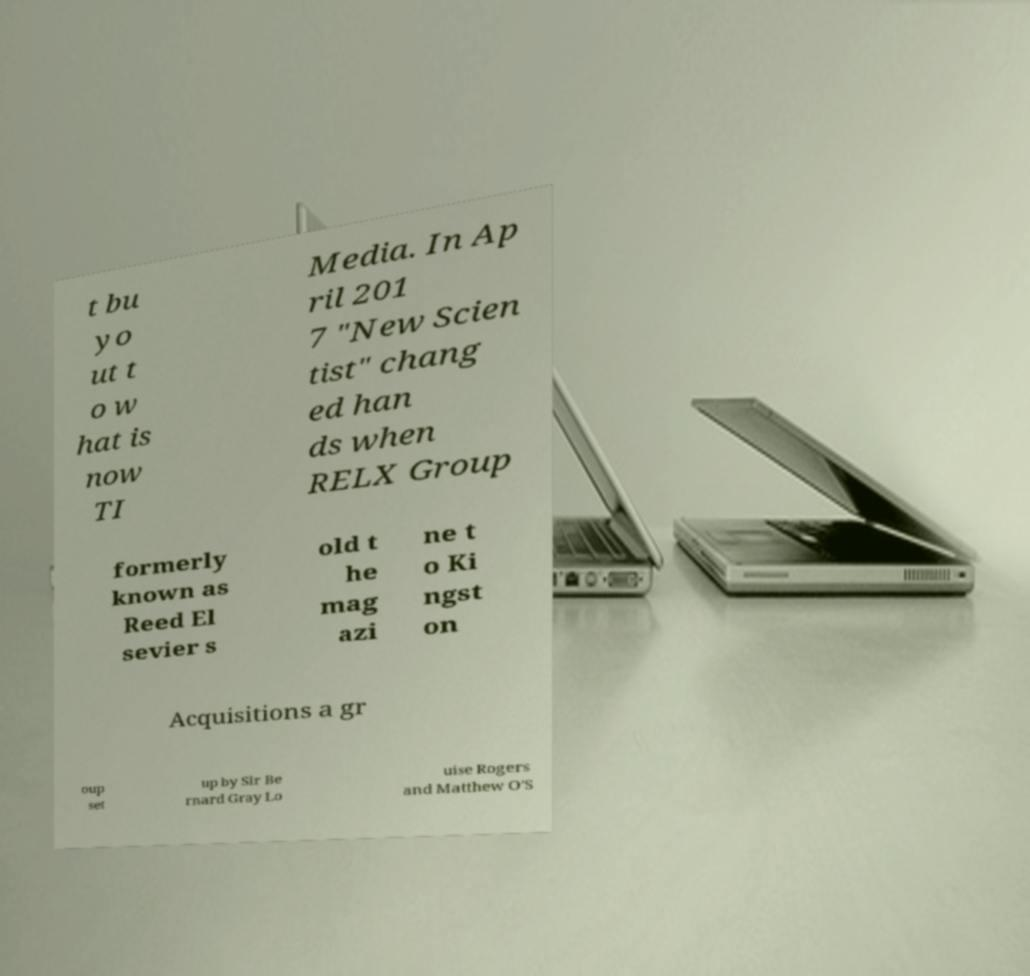I need the written content from this picture converted into text. Can you do that? t bu yo ut t o w hat is now TI Media. In Ap ril 201 7 "New Scien tist" chang ed han ds when RELX Group formerly known as Reed El sevier s old t he mag azi ne t o Ki ngst on Acquisitions a gr oup set up by Sir Be rnard Gray Lo uise Rogers and Matthew O’S 